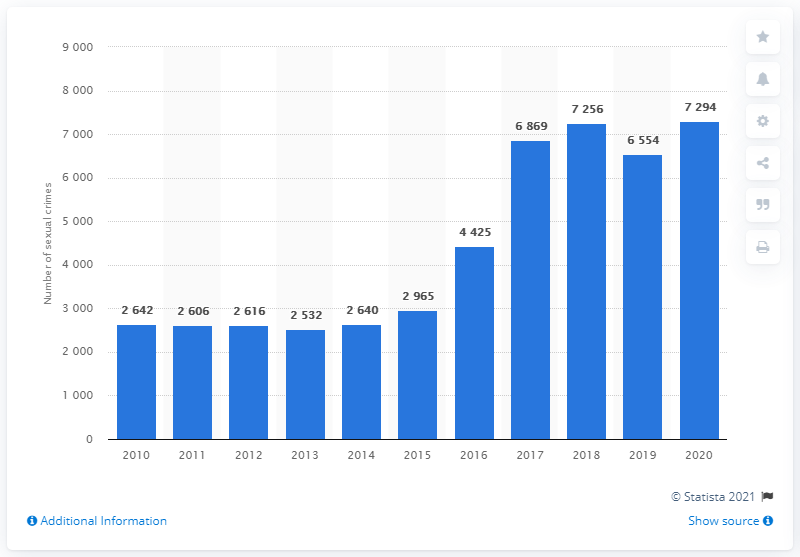Point out several critical features in this image. In 2020, a total of 7,294 sexual crimes were reported in Denmark. 